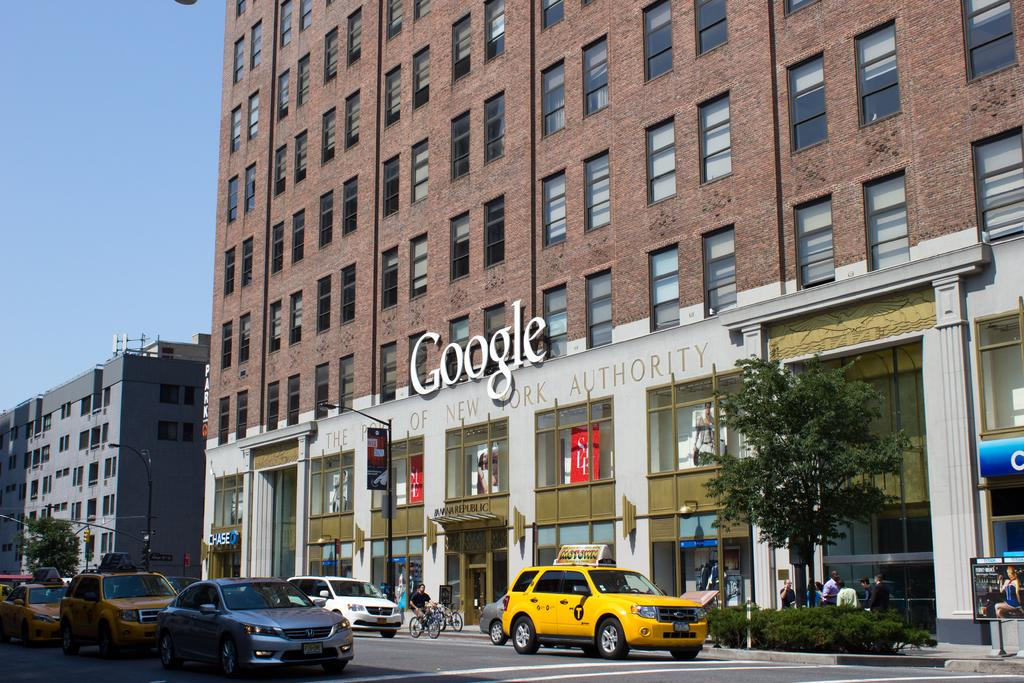<image>
Offer a succinct explanation of the picture presented. A brick building has a sign that says Google and traffic passing beneath it. 